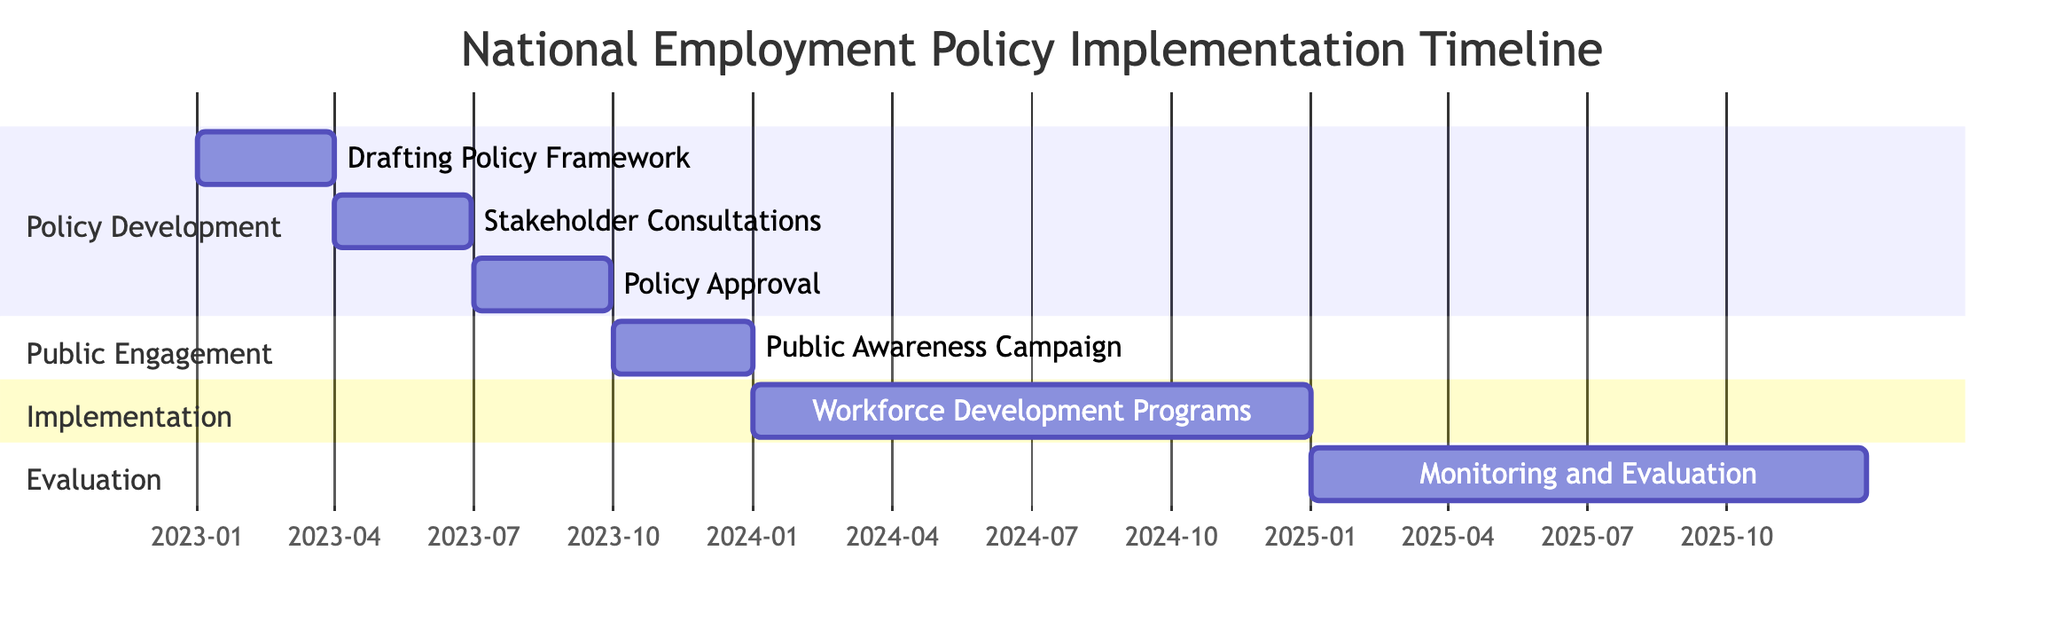What is the duration of the "Drafting Policy Framework" task? The duration of a task in a Gantt chart is determined by the difference between the start and end dates. For "Drafting Policy Framework," the start date is January 1, 2023, and the end date is March 31, 2023. Thus, the duration is from January to March, spanning three months.
Answer: Three months Which stakeholder is involved in the "Policy Approval"? To identify the stakeholders involved in a specific task, we refer to the list available in the diagram. For "Policy Approval," the stakeholders listed are "Parliament" and "Ministry of Labor."
Answer: Parliament, Ministry of Labor How many tasks are included in the "Public Engagement" section? The number of tasks in a section of a Gantt chart can be counted by looking at the entries listed under that specific section. For "Public Engagement," there is only one task: "Public Awareness Campaign."
Answer: One task What is the start date of the "Monitoring and Evaluation" task? To find the start date of a task, we look directly at its entry in the Gantt chart. The "Monitoring and Evaluation" task starts on January 1, 2025.
Answer: January 1, 2025 Which task follows the "Stakeholder Consultations"? The order of tasks in a Gantt chart illustrates their sequence. After "Stakeholder Consultations," which ends on June 30, 2023, the next task listed is "Policy Approval," which starts on July 1, 2023.
Answer: Policy Approval What is the total time span covered in the Gantt chart? The total time span is calculated by identifying the earliest start date and the latest end date within the Gantt chart. The earliest task starts on January 1, 2023, and the latest task ends on December 31, 2025, resulting in a total span of three years.
Answer: Three years Which tasks are set to occur in 2024? To determine tasks in a specific year, we can filter tasks based on their start and end dates. In 2024, the task "Implementation of Workforce Development Programs," running from January 1, 2024, to December 31, 2024, is the only task scheduled.
Answer: Implementation of Workforce Development Programs What is the end date of the "Public Awareness Campaign"? The end date of a task can be directly read from the Gantt chart entry. The "Public Awareness Campaign" ends on December 31, 2023.
Answer: December 31, 2023 